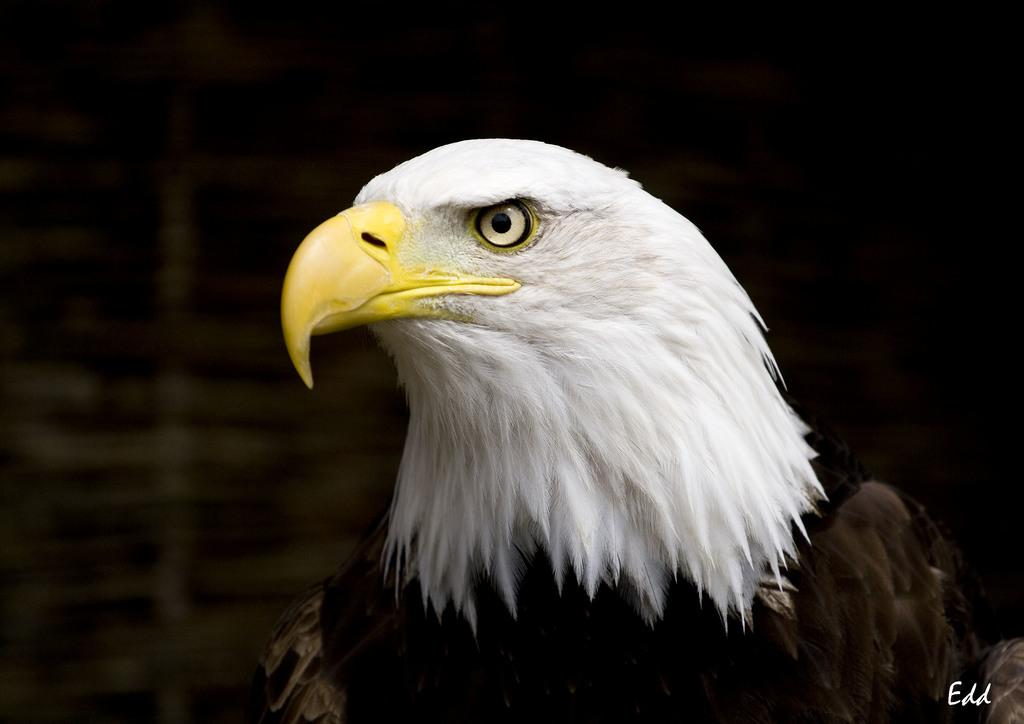What animal is the main subject of the picture? There is an eagle in the picture. What is the color of the background in the image? The background of the image is dark. Can you describe any additional features or elements in the image? There is a watermark in the bottom right corner of the image. What type of pie is being served in the image? There is no pie present in the image; it features an eagle and a dark background. What story is being told in the image? The image does not depict a story; it is a picture of an eagle with a dark background and a watermark. 